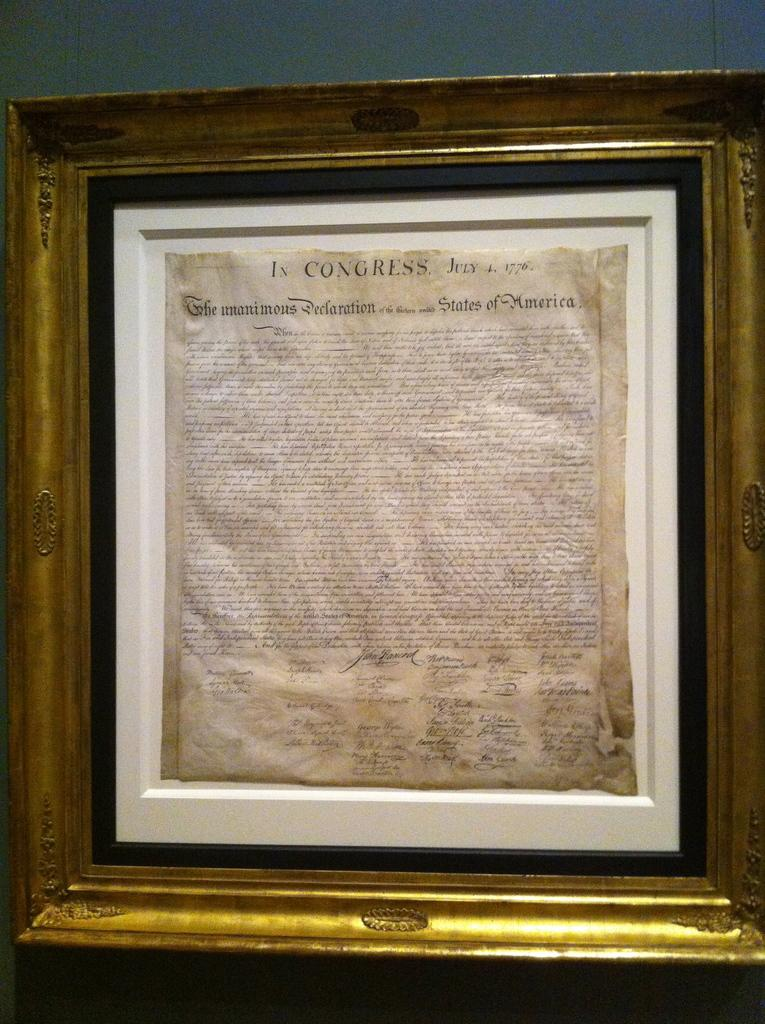<image>
Share a concise interpretation of the image provided. The declaration of the Independence in a white frame which is located inside a bigger black and gold frame. 